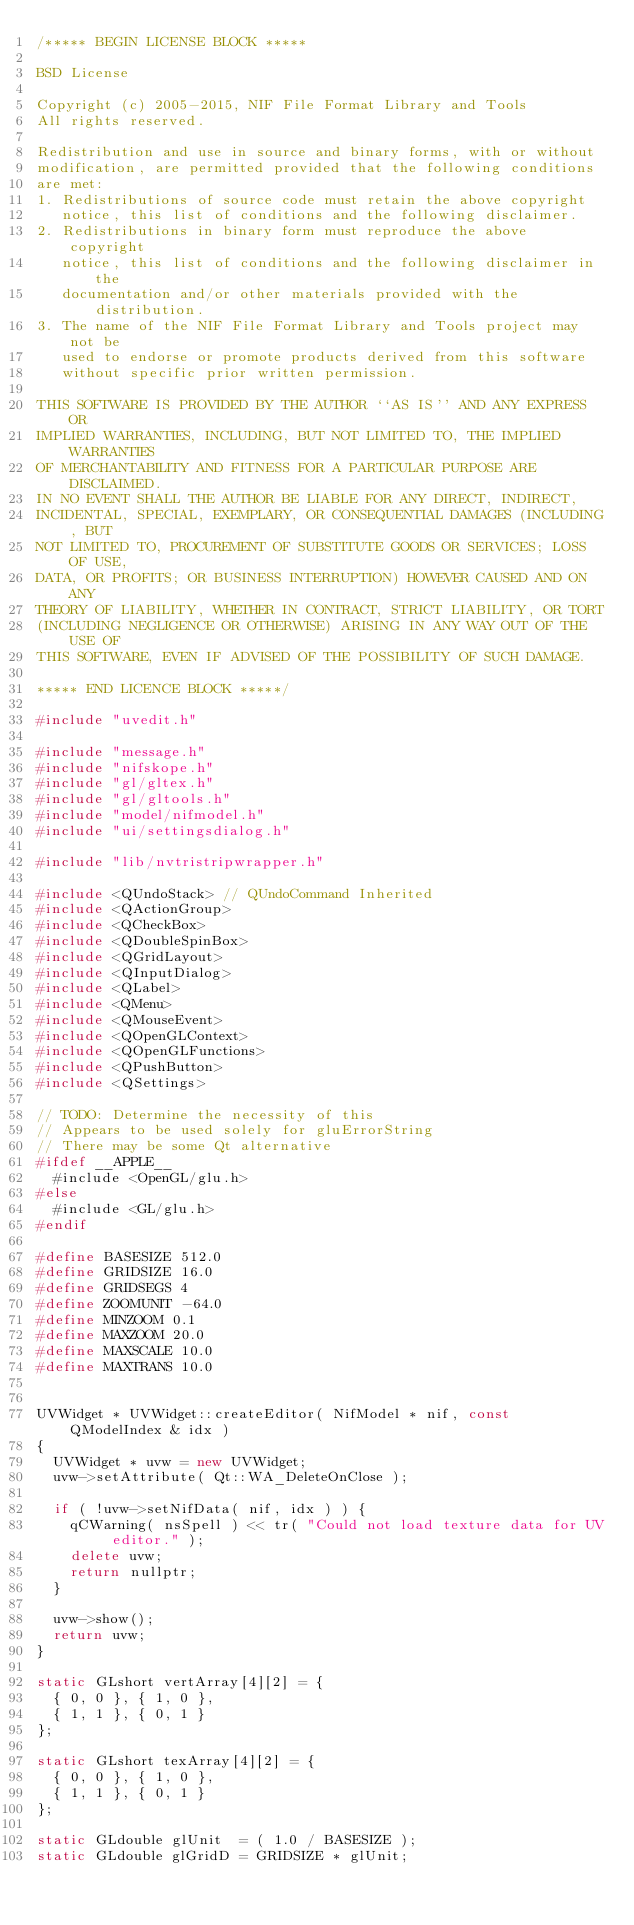Convert code to text. <code><loc_0><loc_0><loc_500><loc_500><_C++_>/***** BEGIN LICENSE BLOCK *****

BSD License

Copyright (c) 2005-2015, NIF File Format Library and Tools
All rights reserved.

Redistribution and use in source and binary forms, with or without
modification, are permitted provided that the following conditions
are met:
1. Redistributions of source code must retain the above copyright
   notice, this list of conditions and the following disclaimer.
2. Redistributions in binary form must reproduce the above copyright
   notice, this list of conditions and the following disclaimer in the
   documentation and/or other materials provided with the distribution.
3. The name of the NIF File Format Library and Tools project may not be
   used to endorse or promote products derived from this software
   without specific prior written permission.

THIS SOFTWARE IS PROVIDED BY THE AUTHOR ``AS IS'' AND ANY EXPRESS OR
IMPLIED WARRANTIES, INCLUDING, BUT NOT LIMITED TO, THE IMPLIED WARRANTIES
OF MERCHANTABILITY AND FITNESS FOR A PARTICULAR PURPOSE ARE DISCLAIMED.
IN NO EVENT SHALL THE AUTHOR BE LIABLE FOR ANY DIRECT, INDIRECT,
INCIDENTAL, SPECIAL, EXEMPLARY, OR CONSEQUENTIAL DAMAGES (INCLUDING, BUT
NOT LIMITED TO, PROCUREMENT OF SUBSTITUTE GOODS OR SERVICES; LOSS OF USE,
DATA, OR PROFITS; OR BUSINESS INTERRUPTION) HOWEVER CAUSED AND ON ANY
THEORY OF LIABILITY, WHETHER IN CONTRACT, STRICT LIABILITY, OR TORT
(INCLUDING NEGLIGENCE OR OTHERWISE) ARISING IN ANY WAY OUT OF THE USE OF
THIS SOFTWARE, EVEN IF ADVISED OF THE POSSIBILITY OF SUCH DAMAGE.

***** END LICENCE BLOCK *****/

#include "uvedit.h"

#include "message.h"
#include "nifskope.h"
#include "gl/gltex.h"
#include "gl/gltools.h"
#include "model/nifmodel.h"
#include "ui/settingsdialog.h"

#include "lib/nvtristripwrapper.h"

#include <QUndoStack> // QUndoCommand Inherited
#include <QActionGroup>
#include <QCheckBox>
#include <QDoubleSpinBox>
#include <QGridLayout>
#include <QInputDialog>
#include <QLabel>
#include <QMenu>
#include <QMouseEvent>
#include <QOpenGLContext>
#include <QOpenGLFunctions>
#include <QPushButton>
#include <QSettings>

// TODO: Determine the necessity of this
// Appears to be used solely for gluErrorString
// There may be some Qt alternative
#ifdef __APPLE__
	#include <OpenGL/glu.h>
#else
	#include <GL/glu.h>
#endif

#define BASESIZE 512.0
#define GRIDSIZE 16.0
#define GRIDSEGS 4
#define ZOOMUNIT -64.0
#define MINZOOM 0.1
#define MAXZOOM 20.0
#define MAXSCALE 10.0
#define MAXTRANS 10.0


UVWidget * UVWidget::createEditor( NifModel * nif, const QModelIndex & idx )
{
	UVWidget * uvw = new UVWidget;
	uvw->setAttribute( Qt::WA_DeleteOnClose );

	if ( !uvw->setNifData( nif, idx ) ) {
		qCWarning( nsSpell ) << tr( "Could not load texture data for UV editor." );
		delete uvw;
		return nullptr;
	}

	uvw->show();
	return uvw;
}

static GLshort vertArray[4][2] = {
	{ 0, 0 }, { 1, 0 },
	{ 1, 1 }, { 0, 1 }
};

static GLshort texArray[4][2] = {
	{ 0, 0 }, { 1, 0 },
	{ 1, 1 }, { 0, 1 }
};

static GLdouble glUnit  = ( 1.0 / BASESIZE );
static GLdouble glGridD = GRIDSIZE * glUnit;
</code> 